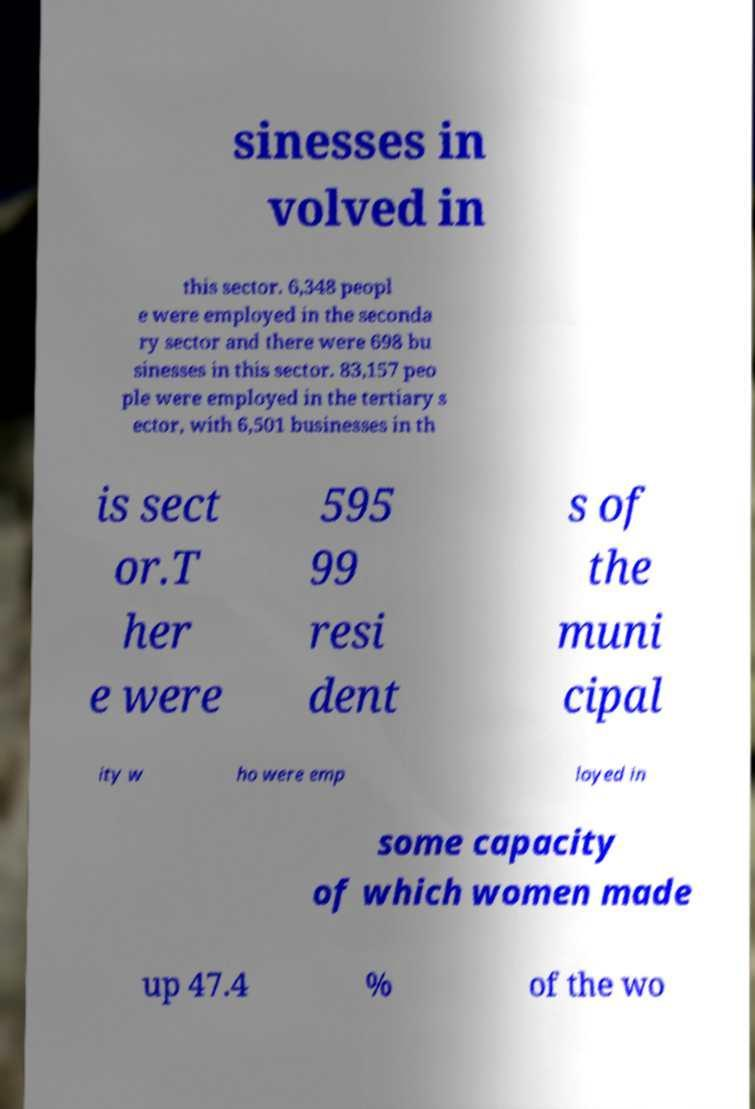Please identify and transcribe the text found in this image. sinesses in volved in this sector. 6,348 peopl e were employed in the seconda ry sector and there were 698 bu sinesses in this sector. 83,157 peo ple were employed in the tertiary s ector, with 6,501 businesses in th is sect or.T her e were 595 99 resi dent s of the muni cipal ity w ho were emp loyed in some capacity of which women made up 47.4 % of the wo 